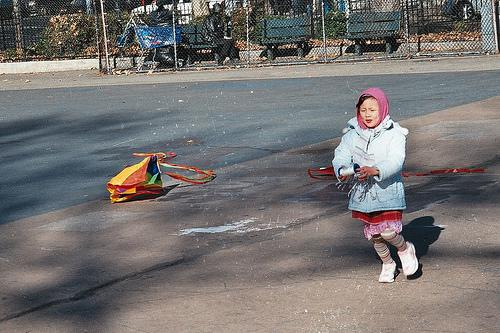Question: what is the woman doing?
Choices:
A. Running.
B. Flying a kite.
C. Skiing.
D. Playing guitar.
Answer with the letter. Answer: B Question: when was this picture taken?
Choices:
A. During the night.
B. At daytime.
C. On my last vacation.
D. In June.
Answer with the letter. Answer: B Question: who is walking in the street?
Choices:
A. The fireman.
B. A police officer.
C. A woman.
D. The president.
Answer with the letter. Answer: C Question: where are the benches?
Choices:
A. Behind the fence.
B. In front of you.
C. Across the street.
D. In the field.
Answer with the letter. Answer: A Question: why is the woman wearing a jacket?
Choices:
A. To be fashionable.
B. It's cold.
C. To hide the coffee stain on her shirt.
D. To match her partner.
Answer with the letter. Answer: B 